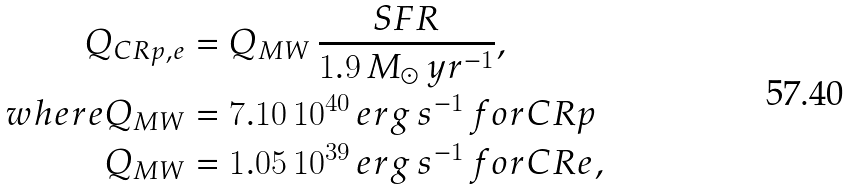Convert formula to latex. <formula><loc_0><loc_0><loc_500><loc_500>Q _ { C R p , e } & = Q _ { M W } \, \frac { S F R } { 1 . 9 \, M _ { \odot } \, y r ^ { - 1 } } , \\ w h e r e Q _ { M W } & = 7 . 1 0 \, 1 0 ^ { 4 0 } \, e r g \, s ^ { - 1 } \, f o r C R p \\ Q _ { M W } & = 1 . 0 5 \, 1 0 ^ { 3 9 } \, e r g \, s ^ { - 1 } \, f o r C R e ,</formula> 